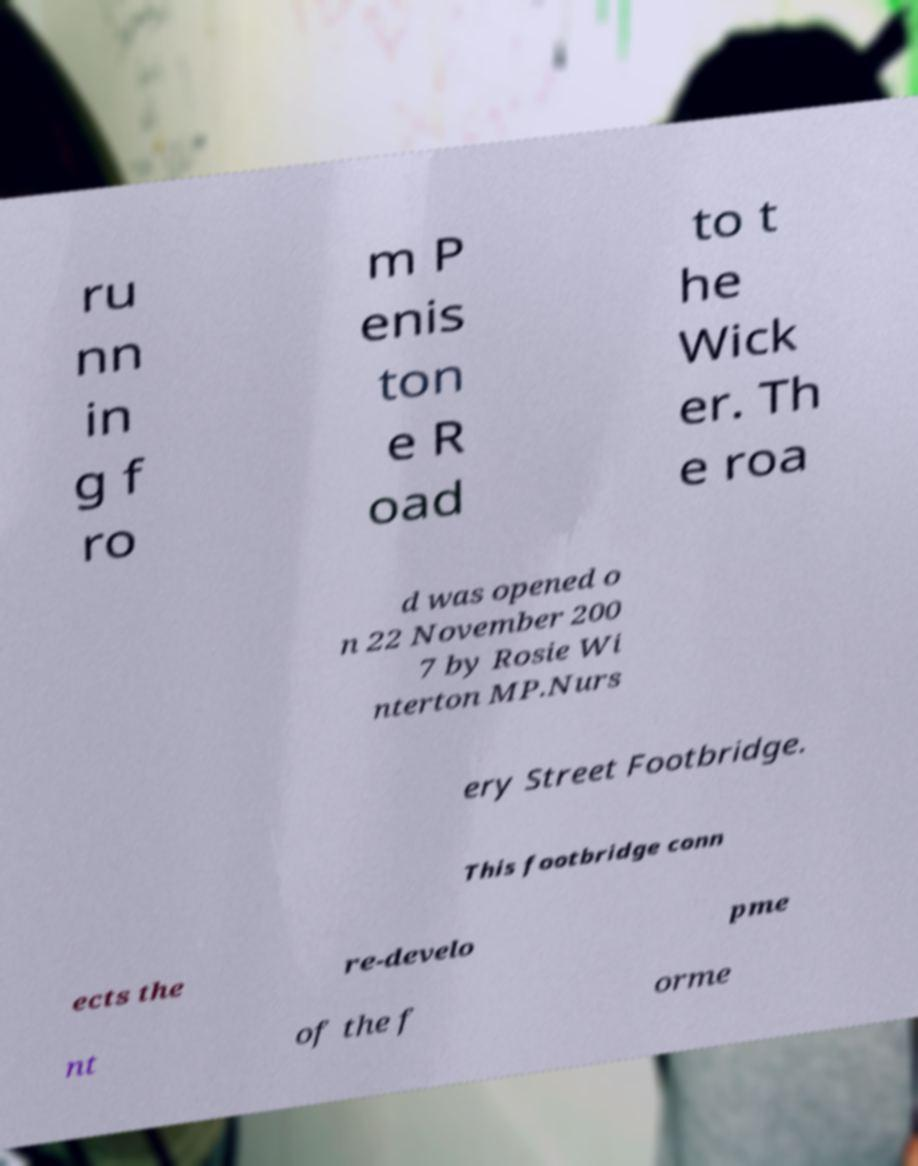Please identify and transcribe the text found in this image. ru nn in g f ro m P enis ton e R oad to t he Wick er. Th e roa d was opened o n 22 November 200 7 by Rosie Wi nterton MP.Nurs ery Street Footbridge. This footbridge conn ects the re-develo pme nt of the f orme 